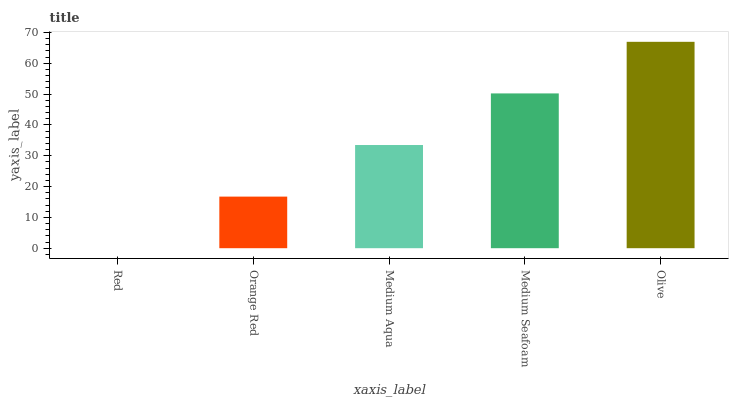Is Red the minimum?
Answer yes or no. Yes. Is Olive the maximum?
Answer yes or no. Yes. Is Orange Red the minimum?
Answer yes or no. No. Is Orange Red the maximum?
Answer yes or no. No. Is Orange Red greater than Red?
Answer yes or no. Yes. Is Red less than Orange Red?
Answer yes or no. Yes. Is Red greater than Orange Red?
Answer yes or no. No. Is Orange Red less than Red?
Answer yes or no. No. Is Medium Aqua the high median?
Answer yes or no. Yes. Is Medium Aqua the low median?
Answer yes or no. Yes. Is Medium Seafoam the high median?
Answer yes or no. No. Is Medium Seafoam the low median?
Answer yes or no. No. 